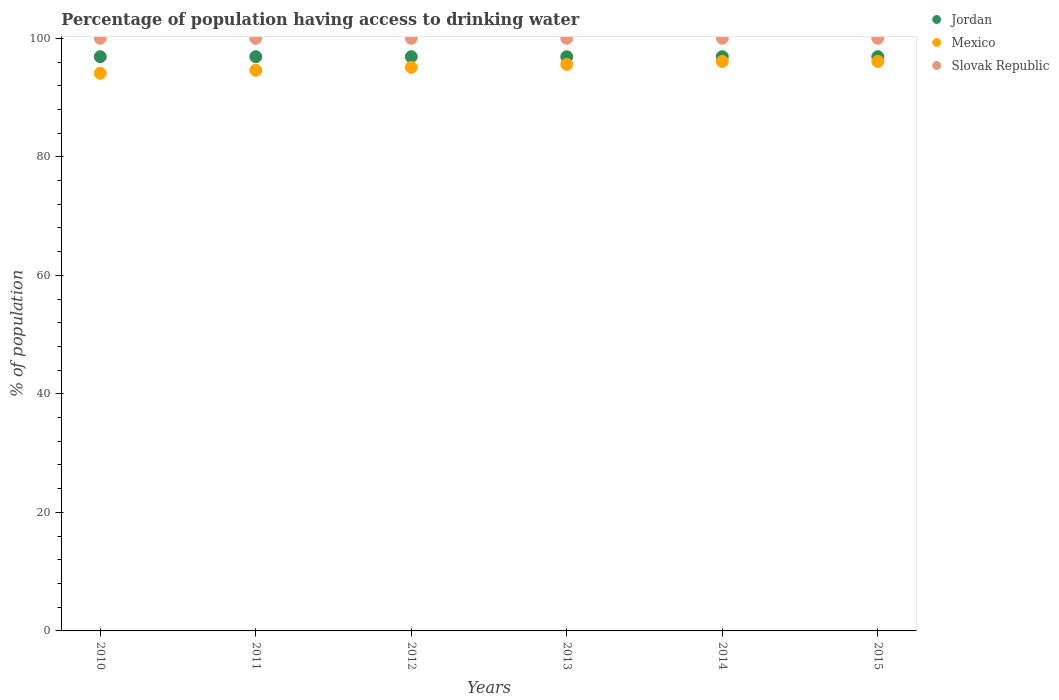What is the percentage of population having access to drinking water in Jordan in 2012?
Your response must be concise. 96.9. Across all years, what is the maximum percentage of population having access to drinking water in Slovak Republic?
Provide a short and direct response. 100. Across all years, what is the minimum percentage of population having access to drinking water in Jordan?
Your answer should be compact. 96.9. What is the total percentage of population having access to drinking water in Slovak Republic in the graph?
Offer a very short reply. 600. What is the difference between the percentage of population having access to drinking water in Mexico in 2011 and the percentage of population having access to drinking water in Slovak Republic in 2013?
Give a very brief answer. -5.4. What is the average percentage of population having access to drinking water in Jordan per year?
Provide a succinct answer. 96.9. In the year 2015, what is the difference between the percentage of population having access to drinking water in Mexico and percentage of population having access to drinking water in Jordan?
Your response must be concise. -0.8. In how many years, is the percentage of population having access to drinking water in Jordan greater than 80 %?
Keep it short and to the point. 6. What is the ratio of the percentage of population having access to drinking water in Mexico in 2011 to that in 2014?
Keep it short and to the point. 0.98. In how many years, is the percentage of population having access to drinking water in Jordan greater than the average percentage of population having access to drinking water in Jordan taken over all years?
Your answer should be compact. 6. How many years are there in the graph?
Provide a succinct answer. 6. Does the graph contain any zero values?
Offer a very short reply. No. How many legend labels are there?
Your answer should be compact. 3. What is the title of the graph?
Give a very brief answer. Percentage of population having access to drinking water. Does "Guinea-Bissau" appear as one of the legend labels in the graph?
Keep it short and to the point. No. What is the label or title of the Y-axis?
Offer a terse response. % of population. What is the % of population of Jordan in 2010?
Provide a succinct answer. 96.9. What is the % of population in Mexico in 2010?
Provide a succinct answer. 94.1. What is the % of population of Jordan in 2011?
Your answer should be very brief. 96.9. What is the % of population in Mexico in 2011?
Your answer should be compact. 94.6. What is the % of population in Jordan in 2012?
Provide a succinct answer. 96.9. What is the % of population of Mexico in 2012?
Provide a short and direct response. 95.1. What is the % of population of Slovak Republic in 2012?
Provide a succinct answer. 100. What is the % of population of Jordan in 2013?
Your answer should be compact. 96.9. What is the % of population of Mexico in 2013?
Your answer should be very brief. 95.6. What is the % of population of Jordan in 2014?
Ensure brevity in your answer.  96.9. What is the % of population in Mexico in 2014?
Your answer should be very brief. 96.1. What is the % of population in Slovak Republic in 2014?
Your answer should be very brief. 100. What is the % of population of Jordan in 2015?
Offer a terse response. 96.9. What is the % of population of Mexico in 2015?
Ensure brevity in your answer.  96.1. Across all years, what is the maximum % of population in Jordan?
Offer a terse response. 96.9. Across all years, what is the maximum % of population in Mexico?
Ensure brevity in your answer.  96.1. Across all years, what is the maximum % of population of Slovak Republic?
Provide a succinct answer. 100. Across all years, what is the minimum % of population of Jordan?
Provide a succinct answer. 96.9. Across all years, what is the minimum % of population of Mexico?
Your answer should be compact. 94.1. Across all years, what is the minimum % of population of Slovak Republic?
Keep it short and to the point. 100. What is the total % of population in Jordan in the graph?
Ensure brevity in your answer.  581.4. What is the total % of population in Mexico in the graph?
Ensure brevity in your answer.  571.6. What is the total % of population in Slovak Republic in the graph?
Offer a very short reply. 600. What is the difference between the % of population in Jordan in 2010 and that in 2011?
Make the answer very short. 0. What is the difference between the % of population of Mexico in 2010 and that in 2011?
Ensure brevity in your answer.  -0.5. What is the difference between the % of population in Slovak Republic in 2010 and that in 2011?
Your response must be concise. 0. What is the difference between the % of population in Jordan in 2010 and that in 2012?
Your answer should be compact. 0. What is the difference between the % of population in Mexico in 2010 and that in 2012?
Provide a succinct answer. -1. What is the difference between the % of population in Slovak Republic in 2010 and that in 2015?
Your answer should be very brief. 0. What is the difference between the % of population of Slovak Republic in 2011 and that in 2013?
Your answer should be compact. 0. What is the difference between the % of population of Jordan in 2011 and that in 2014?
Your response must be concise. 0. What is the difference between the % of population in Mexico in 2011 and that in 2014?
Your answer should be very brief. -1.5. What is the difference between the % of population of Slovak Republic in 2011 and that in 2014?
Your response must be concise. 0. What is the difference between the % of population in Jordan in 2011 and that in 2015?
Ensure brevity in your answer.  0. What is the difference between the % of population in Mexico in 2011 and that in 2015?
Your answer should be compact. -1.5. What is the difference between the % of population of Mexico in 2012 and that in 2014?
Offer a very short reply. -1. What is the difference between the % of population of Slovak Republic in 2012 and that in 2014?
Provide a succinct answer. 0. What is the difference between the % of population of Mexico in 2012 and that in 2015?
Offer a terse response. -1. What is the difference between the % of population of Slovak Republic in 2012 and that in 2015?
Provide a succinct answer. 0. What is the difference between the % of population of Jordan in 2013 and that in 2014?
Your answer should be compact. 0. What is the difference between the % of population in Slovak Republic in 2013 and that in 2014?
Your answer should be compact. 0. What is the difference between the % of population of Jordan in 2013 and that in 2015?
Offer a terse response. 0. What is the difference between the % of population of Jordan in 2010 and the % of population of Slovak Republic in 2011?
Your response must be concise. -3.1. What is the difference between the % of population of Mexico in 2010 and the % of population of Slovak Republic in 2011?
Give a very brief answer. -5.9. What is the difference between the % of population of Jordan in 2010 and the % of population of Mexico in 2012?
Provide a short and direct response. 1.8. What is the difference between the % of population in Mexico in 2010 and the % of population in Slovak Republic in 2012?
Ensure brevity in your answer.  -5.9. What is the difference between the % of population of Jordan in 2010 and the % of population of Mexico in 2014?
Your response must be concise. 0.8. What is the difference between the % of population of Jordan in 2010 and the % of population of Slovak Republic in 2014?
Offer a terse response. -3.1. What is the difference between the % of population of Mexico in 2010 and the % of population of Slovak Republic in 2014?
Provide a succinct answer. -5.9. What is the difference between the % of population of Jordan in 2010 and the % of population of Mexico in 2015?
Your response must be concise. 0.8. What is the difference between the % of population in Jordan in 2010 and the % of population in Slovak Republic in 2015?
Keep it short and to the point. -3.1. What is the difference between the % of population in Mexico in 2011 and the % of population in Slovak Republic in 2012?
Offer a terse response. -5.4. What is the difference between the % of population of Jordan in 2011 and the % of population of Slovak Republic in 2013?
Ensure brevity in your answer.  -3.1. What is the difference between the % of population in Mexico in 2011 and the % of population in Slovak Republic in 2013?
Provide a succinct answer. -5.4. What is the difference between the % of population of Jordan in 2011 and the % of population of Slovak Republic in 2014?
Offer a very short reply. -3.1. What is the difference between the % of population of Jordan in 2011 and the % of population of Slovak Republic in 2015?
Give a very brief answer. -3.1. What is the difference between the % of population of Mexico in 2012 and the % of population of Slovak Republic in 2013?
Provide a succinct answer. -4.9. What is the difference between the % of population of Jordan in 2012 and the % of population of Mexico in 2014?
Offer a terse response. 0.8. What is the difference between the % of population of Jordan in 2012 and the % of population of Mexico in 2015?
Offer a terse response. 0.8. What is the difference between the % of population in Jordan in 2012 and the % of population in Slovak Republic in 2015?
Your response must be concise. -3.1. What is the difference between the % of population of Mexico in 2013 and the % of population of Slovak Republic in 2015?
Your response must be concise. -4.4. What is the difference between the % of population of Jordan in 2014 and the % of population of Mexico in 2015?
Provide a short and direct response. 0.8. What is the difference between the % of population in Mexico in 2014 and the % of population in Slovak Republic in 2015?
Provide a succinct answer. -3.9. What is the average % of population of Jordan per year?
Ensure brevity in your answer.  96.9. What is the average % of population of Mexico per year?
Provide a short and direct response. 95.27. In the year 2011, what is the difference between the % of population of Jordan and % of population of Mexico?
Your answer should be very brief. 2.3. In the year 2011, what is the difference between the % of population in Jordan and % of population in Slovak Republic?
Ensure brevity in your answer.  -3.1. In the year 2011, what is the difference between the % of population of Mexico and % of population of Slovak Republic?
Offer a terse response. -5.4. In the year 2012, what is the difference between the % of population in Jordan and % of population in Mexico?
Provide a succinct answer. 1.8. In the year 2012, what is the difference between the % of population of Mexico and % of population of Slovak Republic?
Your answer should be very brief. -4.9. In the year 2013, what is the difference between the % of population of Jordan and % of population of Slovak Republic?
Provide a succinct answer. -3.1. In the year 2014, what is the difference between the % of population of Mexico and % of population of Slovak Republic?
Your response must be concise. -3.9. In the year 2015, what is the difference between the % of population of Jordan and % of population of Slovak Republic?
Provide a short and direct response. -3.1. In the year 2015, what is the difference between the % of population in Mexico and % of population in Slovak Republic?
Provide a short and direct response. -3.9. What is the ratio of the % of population of Jordan in 2010 to that in 2011?
Make the answer very short. 1. What is the ratio of the % of population in Mexico in 2010 to that in 2011?
Keep it short and to the point. 0.99. What is the ratio of the % of population in Slovak Republic in 2010 to that in 2011?
Your answer should be very brief. 1. What is the ratio of the % of population in Mexico in 2010 to that in 2013?
Give a very brief answer. 0.98. What is the ratio of the % of population of Jordan in 2010 to that in 2014?
Keep it short and to the point. 1. What is the ratio of the % of population of Mexico in 2010 to that in 2014?
Your answer should be very brief. 0.98. What is the ratio of the % of population in Slovak Republic in 2010 to that in 2014?
Your answer should be compact. 1. What is the ratio of the % of population in Jordan in 2010 to that in 2015?
Offer a terse response. 1. What is the ratio of the % of population of Mexico in 2010 to that in 2015?
Your answer should be very brief. 0.98. What is the ratio of the % of population in Slovak Republic in 2010 to that in 2015?
Keep it short and to the point. 1. What is the ratio of the % of population of Mexico in 2011 to that in 2012?
Ensure brevity in your answer.  0.99. What is the ratio of the % of population of Slovak Republic in 2011 to that in 2013?
Offer a terse response. 1. What is the ratio of the % of population of Jordan in 2011 to that in 2014?
Provide a succinct answer. 1. What is the ratio of the % of population in Mexico in 2011 to that in 2014?
Give a very brief answer. 0.98. What is the ratio of the % of population of Slovak Republic in 2011 to that in 2014?
Offer a very short reply. 1. What is the ratio of the % of population of Jordan in 2011 to that in 2015?
Keep it short and to the point. 1. What is the ratio of the % of population in Mexico in 2011 to that in 2015?
Keep it short and to the point. 0.98. What is the ratio of the % of population in Jordan in 2012 to that in 2013?
Offer a terse response. 1. What is the ratio of the % of population in Slovak Republic in 2012 to that in 2013?
Your answer should be compact. 1. What is the ratio of the % of population in Jordan in 2012 to that in 2014?
Offer a terse response. 1. What is the ratio of the % of population in Slovak Republic in 2012 to that in 2015?
Offer a terse response. 1. What is the ratio of the % of population of Mexico in 2013 to that in 2014?
Offer a very short reply. 0.99. What is the ratio of the % of population in Mexico in 2013 to that in 2015?
Make the answer very short. 0.99. What is the ratio of the % of population in Jordan in 2014 to that in 2015?
Offer a very short reply. 1. What is the ratio of the % of population in Slovak Republic in 2014 to that in 2015?
Give a very brief answer. 1. What is the difference between the highest and the lowest % of population of Jordan?
Your response must be concise. 0. What is the difference between the highest and the lowest % of population of Slovak Republic?
Your answer should be very brief. 0. 